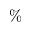<formula> <loc_0><loc_0><loc_500><loc_500>\%</formula> 